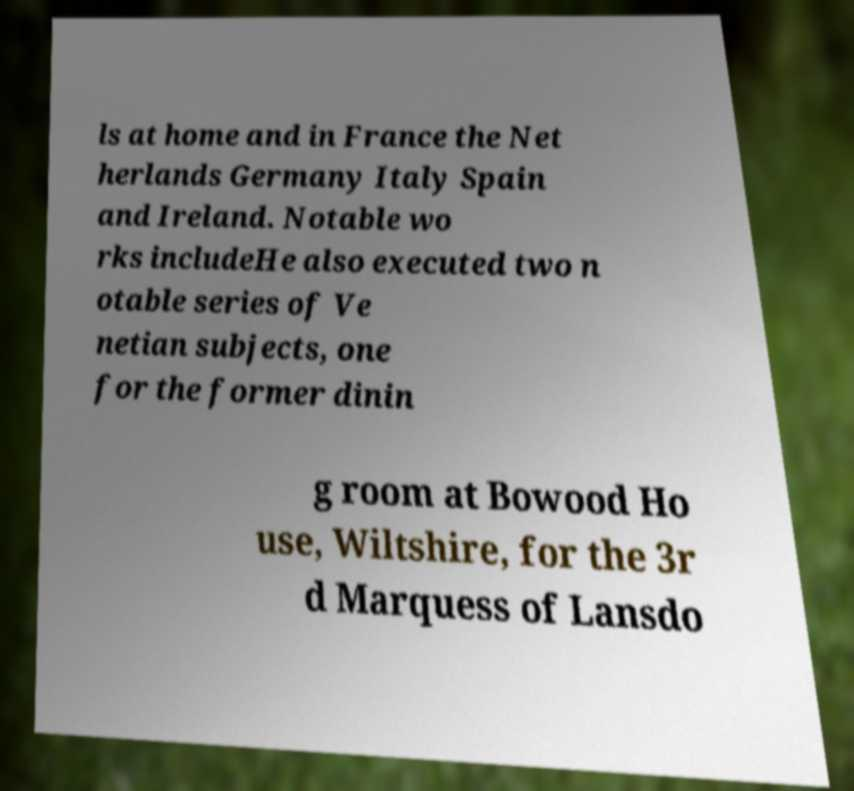Can you accurately transcribe the text from the provided image for me? ls at home and in France the Net herlands Germany Italy Spain and Ireland. Notable wo rks includeHe also executed two n otable series of Ve netian subjects, one for the former dinin g room at Bowood Ho use, Wiltshire, for the 3r d Marquess of Lansdo 